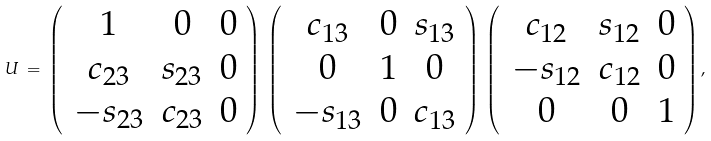Convert formula to latex. <formula><loc_0><loc_0><loc_500><loc_500>U \, = \, \left ( \, \begin{array} { c c c } { 1 } & { 0 } & { 0 } \\ { { c _ { 2 3 } } } & { { s _ { 2 3 } } } & { 0 } \\ { { - s _ { 2 3 } } } & { { c _ { 2 3 } } } & { 0 } \end{array} \right ) \, \left ( \, \begin{array} { c c c } { { c _ { 1 3 } } } & { 0 } & { { s _ { 1 3 } } } \\ { 0 } & { 1 } & { 0 } \\ { { - s _ { 1 3 } } } & { 0 } & { { c _ { 1 3 } } } \end{array} \right ) \, \left ( \, \begin{array} { c c c } { { c _ { 1 2 } } } & { { s _ { 1 2 } } } & { 0 } \\ { { - s _ { 1 2 } } } & { { c _ { 1 2 } } } & { 0 } \\ { 0 } & { 0 } & { 1 } \end{array} \right ) ,</formula> 